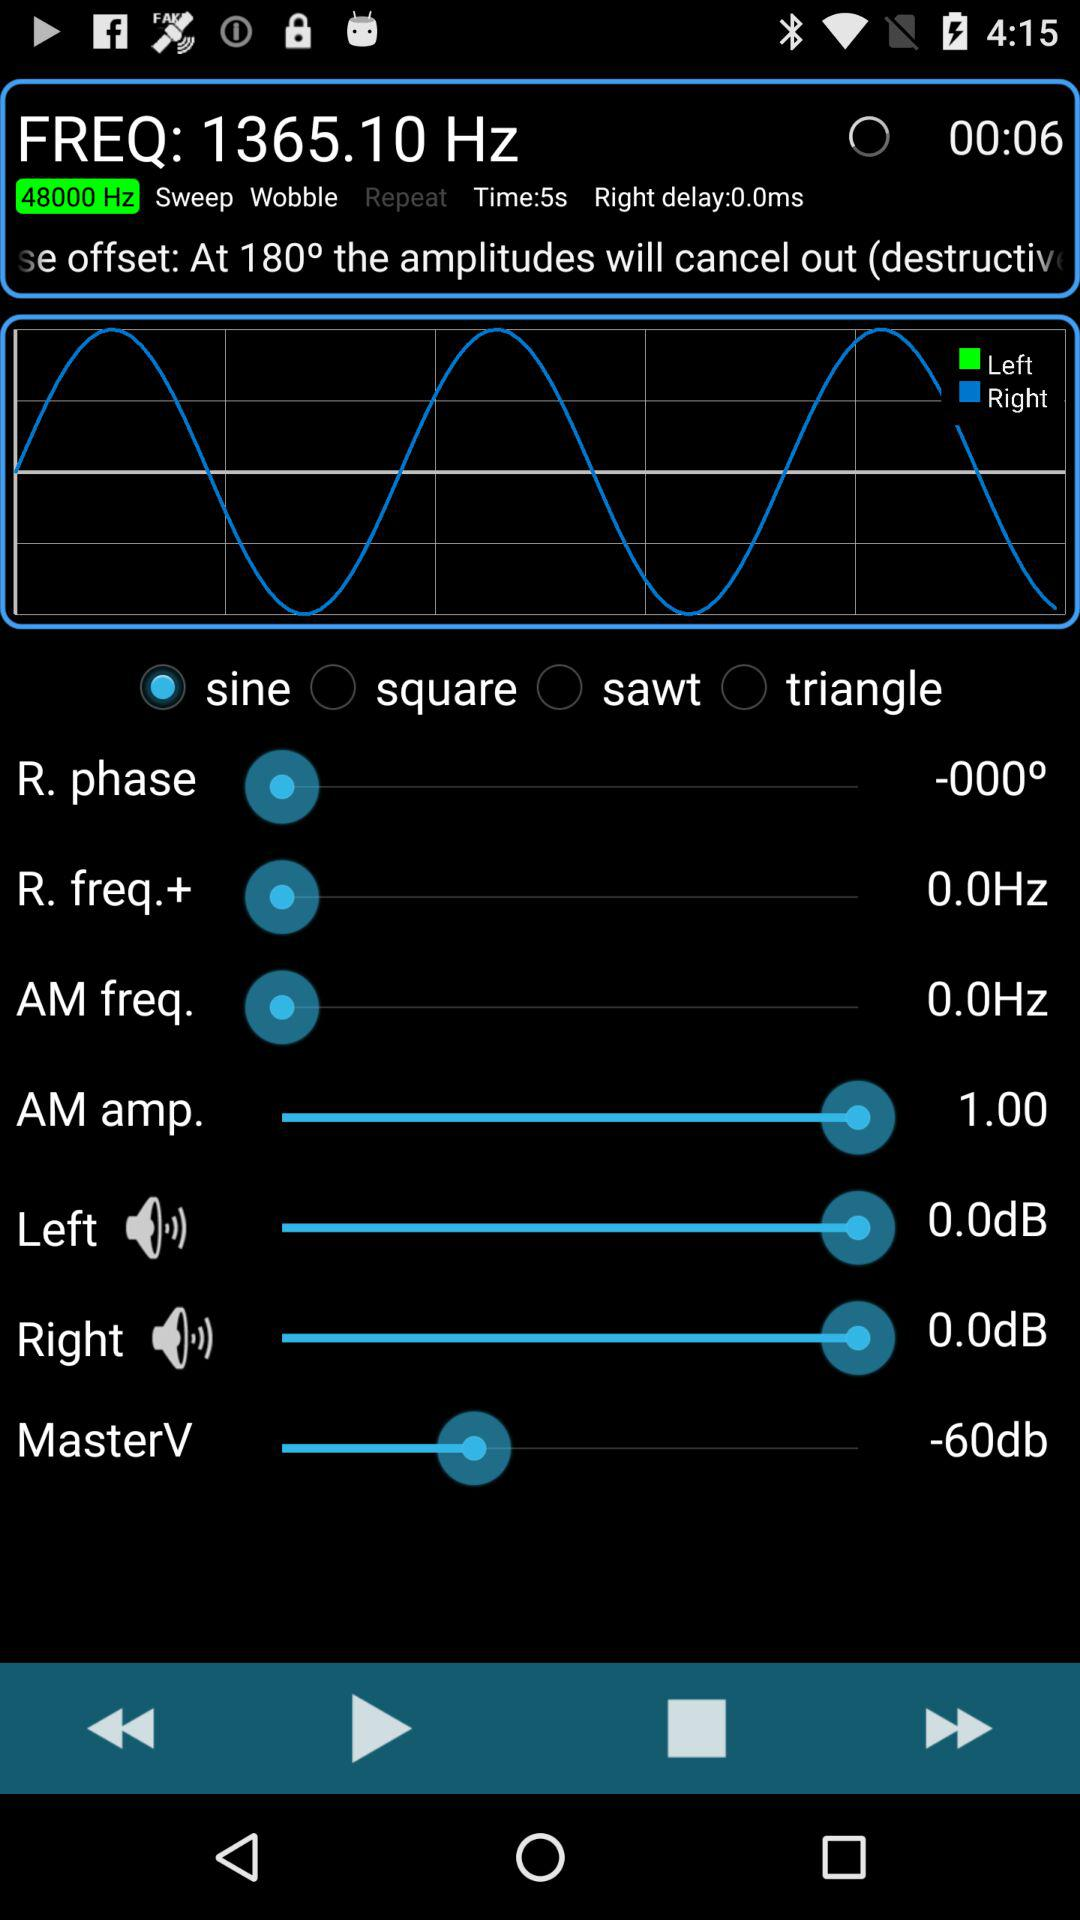What is the value of the right delay?
Answer the question using a single word or phrase. 0.0ms 